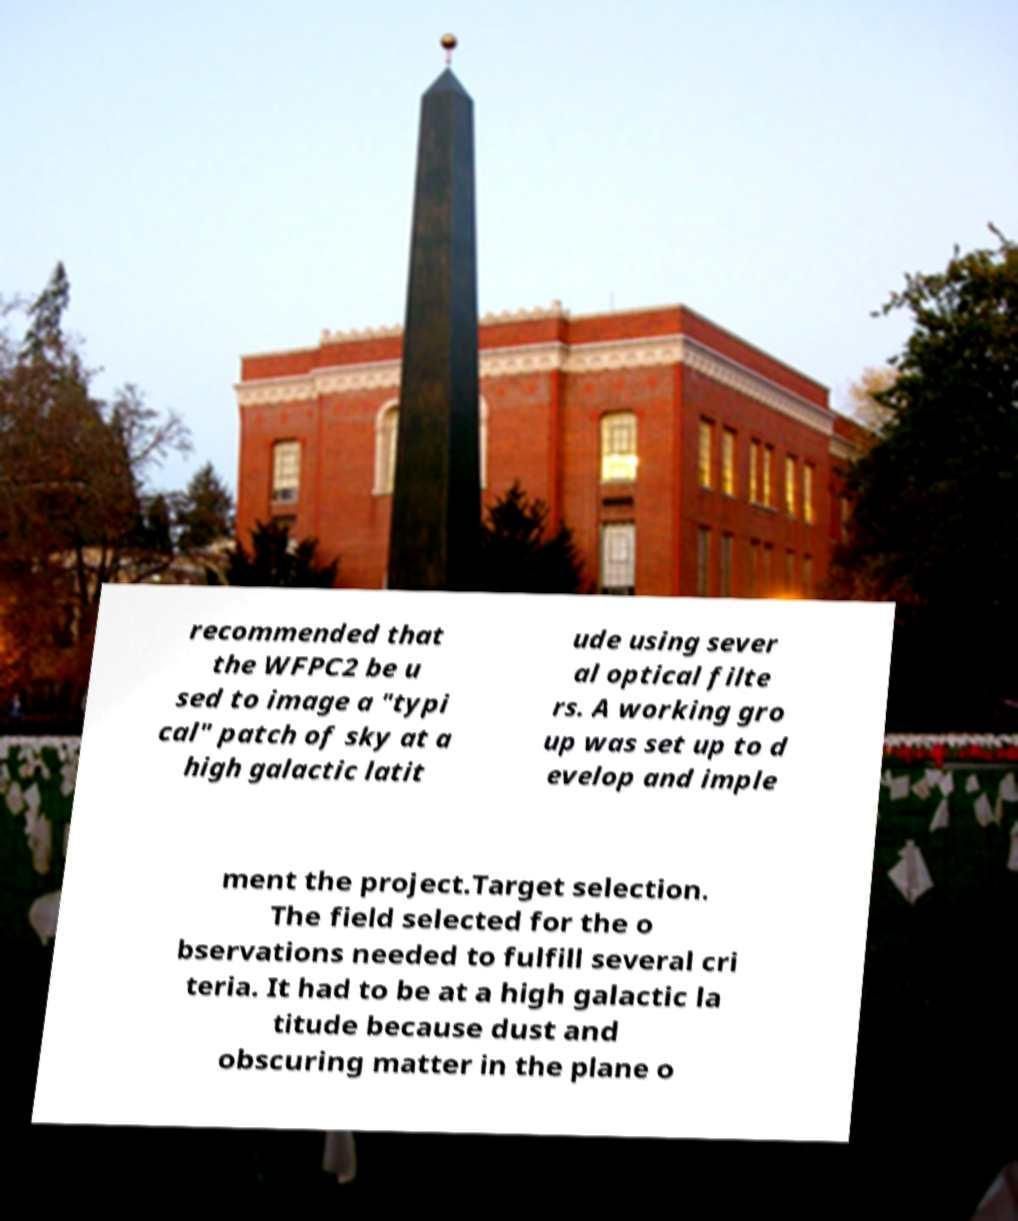There's text embedded in this image that I need extracted. Can you transcribe it verbatim? recommended that the WFPC2 be u sed to image a "typi cal" patch of sky at a high galactic latit ude using sever al optical filte rs. A working gro up was set up to d evelop and imple ment the project.Target selection. The field selected for the o bservations needed to fulfill several cri teria. It had to be at a high galactic la titude because dust and obscuring matter in the plane o 